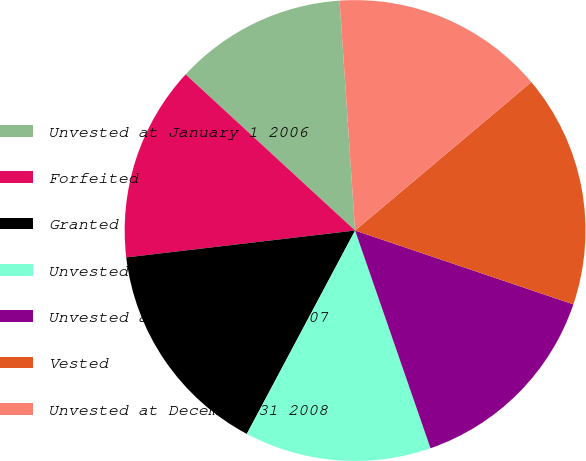Convert chart. <chart><loc_0><loc_0><loc_500><loc_500><pie_chart><fcel>Unvested at January 1 2006<fcel>Forfeited<fcel>Granted<fcel>Unvested at December 31 2006<fcel>Unvested at December 31 2007<fcel>Vested<fcel>Unvested at December 31 2008<nl><fcel>12.08%<fcel>13.71%<fcel>15.35%<fcel>13.09%<fcel>14.5%<fcel>16.33%<fcel>14.93%<nl></chart> 